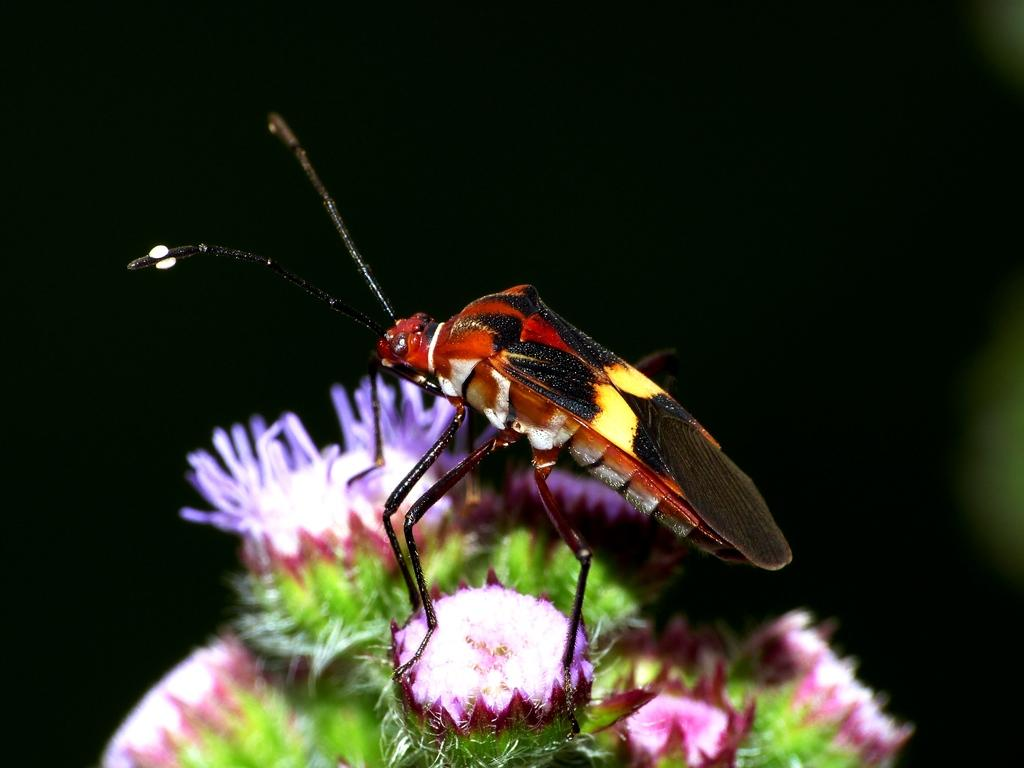What type of creature can be seen in the image? There is an insect in the image. What is the insect doing in the image? The insect is standing on an object. What flavor of plastic is the insect standing on in the image? There is no plastic or flavor mentioned in the image, as it only features an insect standing on an object. 